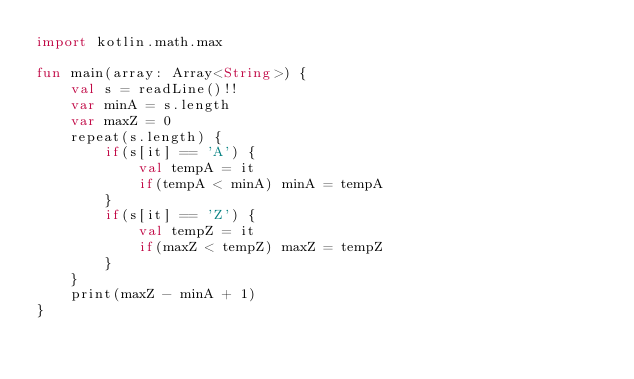<code> <loc_0><loc_0><loc_500><loc_500><_Kotlin_>import kotlin.math.max

fun main(array: Array<String>) {
    val s = readLine()!!
    var minA = s.length
    var maxZ = 0
    repeat(s.length) {
        if(s[it] == 'A') {
            val tempA = it
            if(tempA < minA) minA = tempA
        }
        if(s[it] == 'Z') {
            val tempZ = it
            if(maxZ < tempZ) maxZ = tempZ
        }
    }
    print(maxZ - minA + 1)
}</code> 